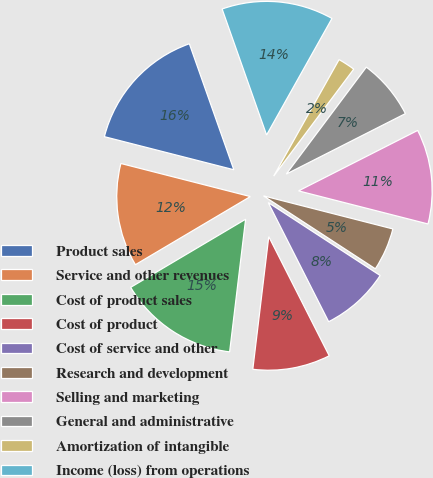Convert chart to OTSL. <chart><loc_0><loc_0><loc_500><loc_500><pie_chart><fcel>Product sales<fcel>Service and other revenues<fcel>Cost of product sales<fcel>Cost of product<fcel>Cost of service and other<fcel>Research and development<fcel>Selling and marketing<fcel>General and administrative<fcel>Amortization of intangible<fcel>Income (loss) from operations<nl><fcel>15.62%<fcel>12.5%<fcel>14.58%<fcel>9.38%<fcel>8.34%<fcel>5.21%<fcel>11.46%<fcel>7.3%<fcel>2.09%<fcel>13.54%<nl></chart> 